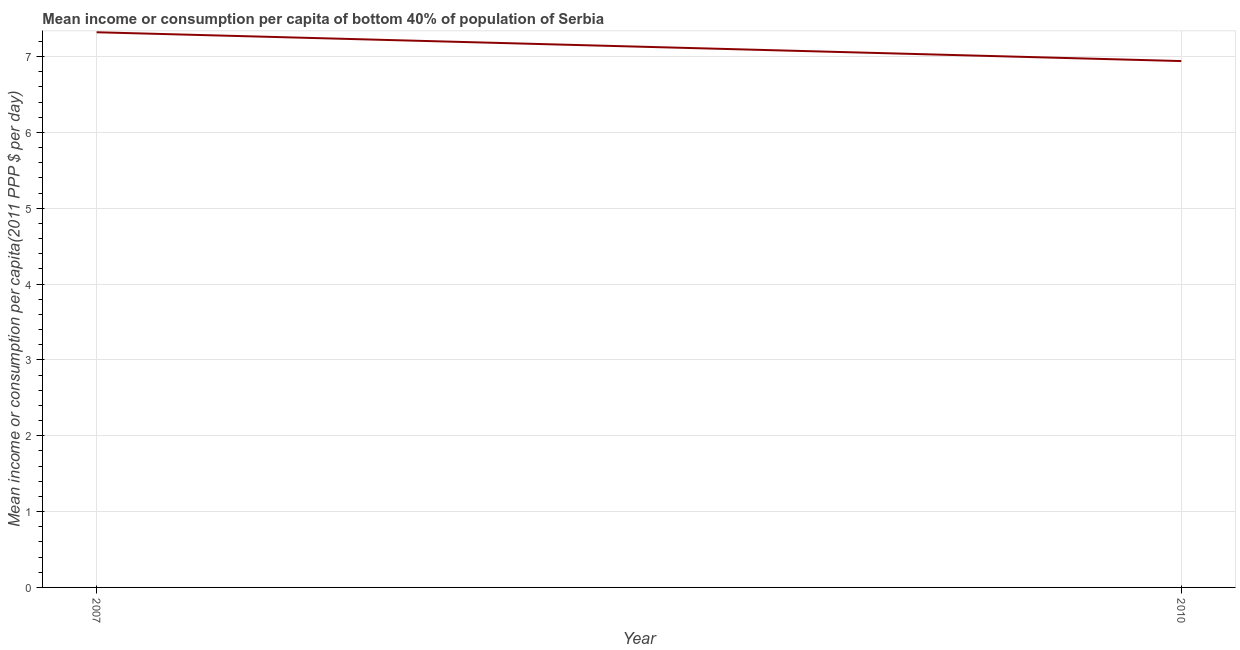What is the mean income or consumption in 2010?
Your response must be concise. 6.94. Across all years, what is the maximum mean income or consumption?
Your answer should be compact. 7.32. Across all years, what is the minimum mean income or consumption?
Ensure brevity in your answer.  6.94. What is the sum of the mean income or consumption?
Make the answer very short. 14.26. What is the difference between the mean income or consumption in 2007 and 2010?
Make the answer very short. 0.38. What is the average mean income or consumption per year?
Your answer should be compact. 7.13. What is the median mean income or consumption?
Offer a very short reply. 7.13. What is the ratio of the mean income or consumption in 2007 to that in 2010?
Give a very brief answer. 1.05. Is the mean income or consumption in 2007 less than that in 2010?
Your answer should be very brief. No. How many lines are there?
Your response must be concise. 1. How many years are there in the graph?
Offer a very short reply. 2. What is the difference between two consecutive major ticks on the Y-axis?
Offer a very short reply. 1. What is the title of the graph?
Your answer should be compact. Mean income or consumption per capita of bottom 40% of population of Serbia. What is the label or title of the X-axis?
Give a very brief answer. Year. What is the label or title of the Y-axis?
Make the answer very short. Mean income or consumption per capita(2011 PPP $ per day). What is the Mean income or consumption per capita(2011 PPP $ per day) of 2007?
Your answer should be very brief. 7.32. What is the Mean income or consumption per capita(2011 PPP $ per day) of 2010?
Your response must be concise. 6.94. What is the difference between the Mean income or consumption per capita(2011 PPP $ per day) in 2007 and 2010?
Offer a very short reply. 0.38. What is the ratio of the Mean income or consumption per capita(2011 PPP $ per day) in 2007 to that in 2010?
Your answer should be very brief. 1.05. 